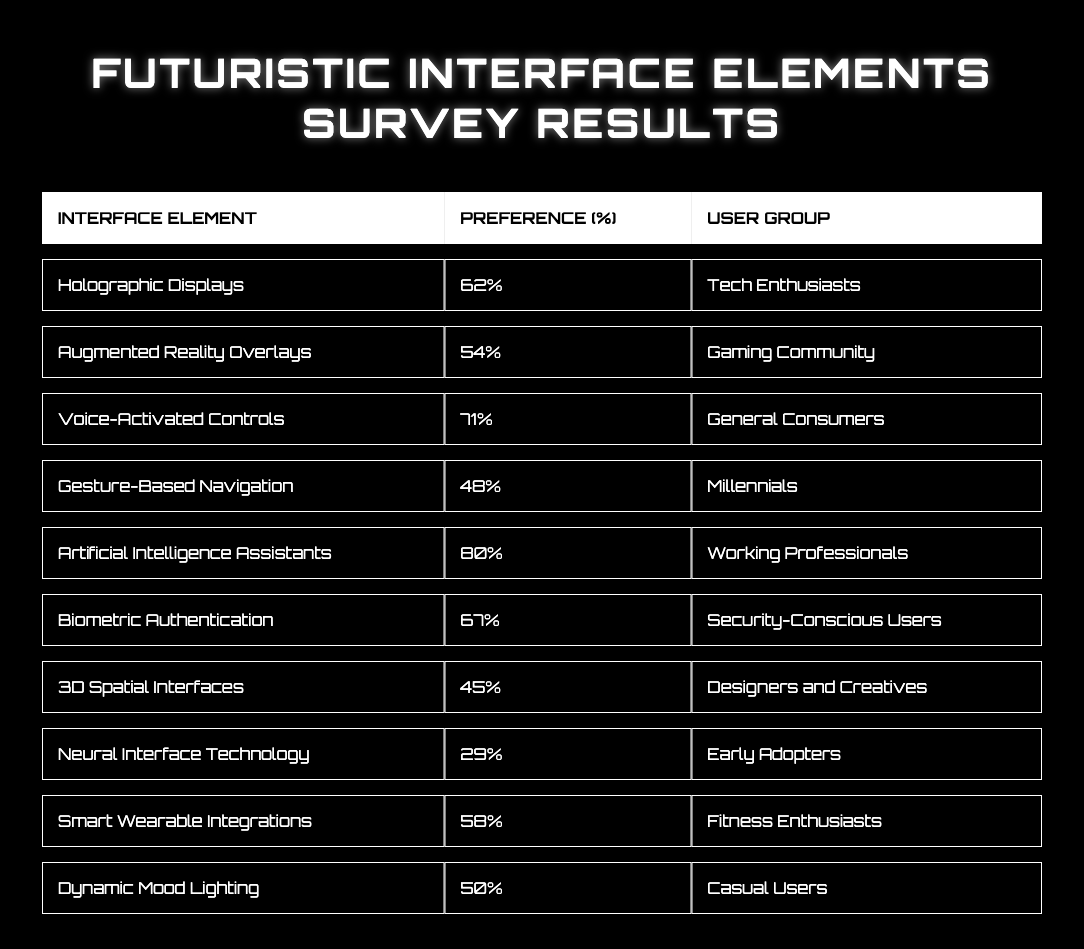What interface element is preferred by the highest percentage of users? The table shows that the interface element with the highest percentage preference is "Artificial Intelligence Assistants" with 80%.
Answer: 80% Which user group prefers Voice-Activated Controls the most? According to the table, "Voice-Activated Controls" has a percentage preference of 71% among "General Consumers."
Answer: General Consumers What is the percentage preference for Augmented Reality Overlays? The table indicates that "Augmented Reality Overlays" has a percentage preference of 54%.
Answer: 54% Is there a user group that prefers Neural Interface Technology more than 30%? The table shows that "Neural Interface Technology" has a preference of 29%, which is less than 30%, so no user group prefers it more than that percentage.
Answer: No What is the average percentage preference for the Tech Enthusiasts and Security-Conscious Users? The percentages for Tech Enthusiasts (62%) and Security-Conscious Users (67%) can be summed up (62 + 67 = 129), then divided by 2 to find the average, which is 129/2 = 64.5%.
Answer: 64.5% Which interface elements have a percentage preference below 50%? Reviewing the table shows that "Gesture-Based Navigation" (48%), "3D Spatial Interfaces" (45%), and "Neural Interface Technology" (29%) all have preferences below 50%.
Answer: Gesture-Based Navigation, 3D Spatial Interfaces, Neural Interface Technology How does the preference for Smart Wearable Integrations compare to that for Gesture-Based Navigation? "Smart Wearable Integrations" has a preference of 58%, while "Gesture-Based Navigation" has 48%. The difference is 58 - 48 = 10, meaning Smart Wearable Integrations is preferred by 10% more users.
Answer: Smart Wearable Integrations is preferred by 10% more users Which user group's preference is closer to the overall average than any others? To determine the overall average of all percentages (62 + 54 + 71 + 48 + 80 + 67 + 45 + 29 + 58 + 50 = 564, then 564/10 = 56.4%). "Voice-Activated Controls" (71%) and "Biometric Authentication" (67%) are considerably higher, but the closest is "Dynamic Mood Lighting" at 50%, which is 6.4% lower than the average.
Answer: Dynamic Mood Lighting What percentage of the Gaming Community prefers Augmented Reality Overlays? The table states that the Gaming Community has a preference of 54% for Augmented Reality Overlays.
Answer: 54% How many user groups have a preference percentage greater than 60%? From the table, the interface elements preferred by over 60% are "Artificial Intelligence Assistants" (80%), "Biometric Authentication" (67%), and "Voice-Activated Controls" (71%), totaling 3 user groups.
Answer: 3 